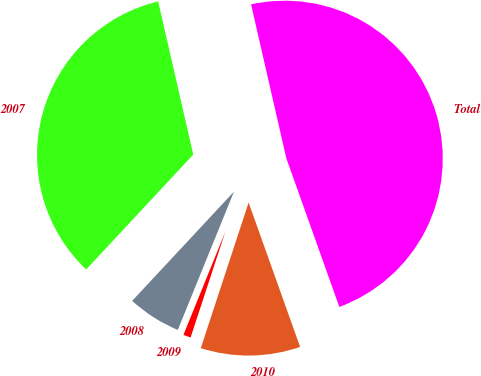Convert chart. <chart><loc_0><loc_0><loc_500><loc_500><pie_chart><fcel>2007<fcel>2008<fcel>2009<fcel>2010<fcel>Total<nl><fcel>34.47%<fcel>5.8%<fcel>1.09%<fcel>10.5%<fcel>48.13%<nl></chart> 